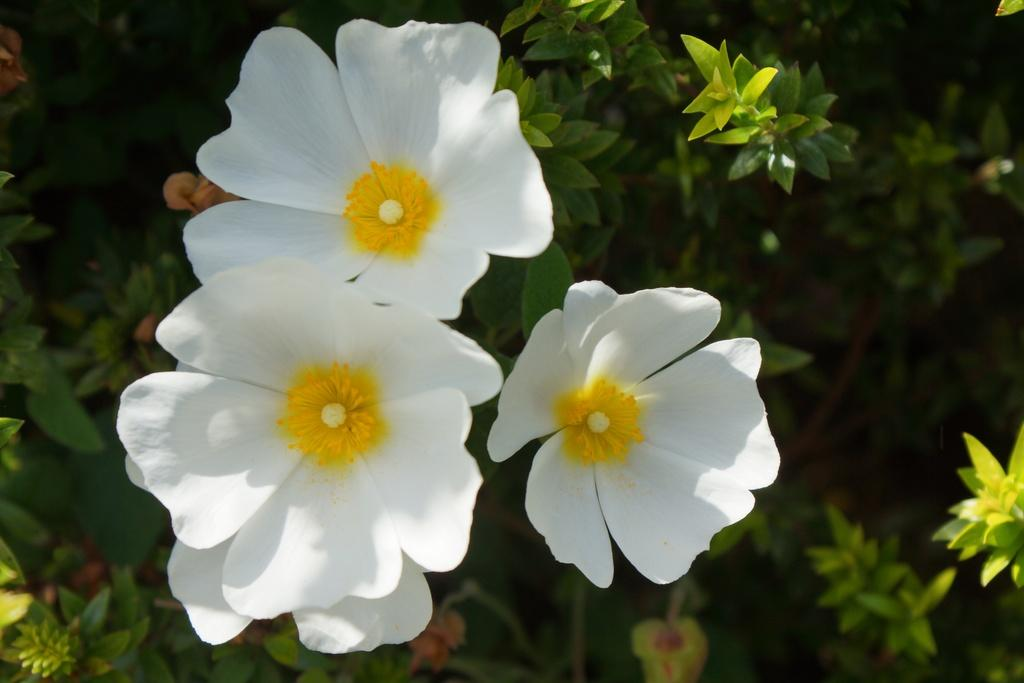How many white flowers are on the plant in the image? There are three white flowers on a plant in the image. What else can be seen in the image besides the flowers? There are plants visible in the background of the image. What type of toys are being used for pleasure in the image? There are no toys or references to pleasure in the image; it features three white flowers on a plant and plants in the background. 